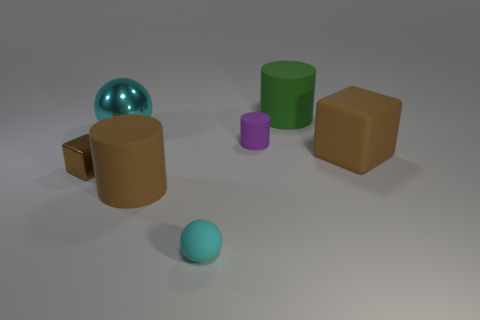Add 1 brown rubber objects. How many objects exist? 8 Subtract all spheres. How many objects are left? 5 Add 3 big rubber things. How many big rubber things are left? 6 Add 4 tiny cyan shiny cubes. How many tiny cyan shiny cubes exist? 4 Subtract 0 gray cylinders. How many objects are left? 7 Subtract all big rubber cylinders. Subtract all brown matte cylinders. How many objects are left? 4 